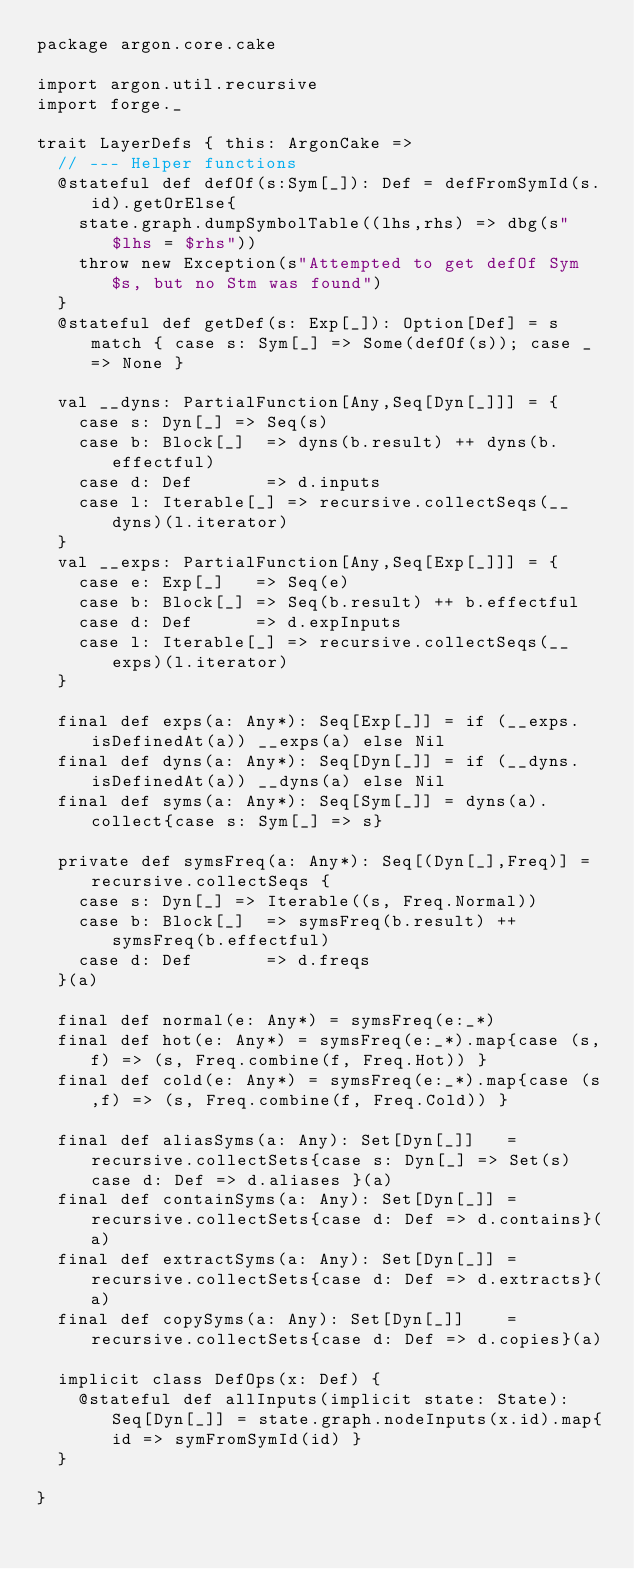<code> <loc_0><loc_0><loc_500><loc_500><_Scala_>package argon.core.cake

import argon.util.recursive
import forge._

trait LayerDefs { this: ArgonCake =>
  // --- Helper functions
  @stateful def defOf(s:Sym[_]): Def = defFromSymId(s.id).getOrElse{
    state.graph.dumpSymbolTable((lhs,rhs) => dbg(s"$lhs = $rhs"))
    throw new Exception(s"Attempted to get defOf Sym $s, but no Stm was found")
  }
  @stateful def getDef(s: Exp[_]): Option[Def] = s match { case s: Sym[_] => Some(defOf(s)); case _ => None }

  val __dyns: PartialFunction[Any,Seq[Dyn[_]]] = {
    case s: Dyn[_] => Seq(s)
    case b: Block[_]  => dyns(b.result) ++ dyns(b.effectful)
    case d: Def       => d.inputs
    case l: Iterable[_] => recursive.collectSeqs(__dyns)(l.iterator)
  }
  val __exps: PartialFunction[Any,Seq[Exp[_]]] = {
    case e: Exp[_]   => Seq(e)
    case b: Block[_] => Seq(b.result) ++ b.effectful
    case d: Def      => d.expInputs
    case l: Iterable[_] => recursive.collectSeqs(__exps)(l.iterator)
  }

  final def exps(a: Any*): Seq[Exp[_]] = if (__exps.isDefinedAt(a)) __exps(a) else Nil
  final def dyns(a: Any*): Seq[Dyn[_]] = if (__dyns.isDefinedAt(a)) __dyns(a) else Nil
  final def syms(a: Any*): Seq[Sym[_]] = dyns(a).collect{case s: Sym[_] => s}

  private def symsFreq(a: Any*): Seq[(Dyn[_],Freq)] = recursive.collectSeqs {
    case s: Dyn[_] => Iterable((s, Freq.Normal))
    case b: Block[_]  => symsFreq(b.result) ++ symsFreq(b.effectful)
    case d: Def       => d.freqs
  }(a)

  final def normal(e: Any*) = symsFreq(e:_*)
  final def hot(e: Any*) = symsFreq(e:_*).map{case (s,f) => (s, Freq.combine(f, Freq.Hot)) }
  final def cold(e: Any*) = symsFreq(e:_*).map{case (s,f) => (s, Freq.combine(f, Freq.Cold)) }

  final def aliasSyms(a: Any): Set[Dyn[_]]   = recursive.collectSets{case s: Dyn[_] => Set(s) case d: Def => d.aliases }(a)
  final def containSyms(a: Any): Set[Dyn[_]] = recursive.collectSets{case d: Def => d.contains}(a)
  final def extractSyms(a: Any): Set[Dyn[_]] = recursive.collectSets{case d: Def => d.extracts}(a)
  final def copySyms(a: Any): Set[Dyn[_]]    = recursive.collectSets{case d: Def => d.copies}(a)

  implicit class DefOps(x: Def) {
    @stateful def allInputs(implicit state: State): Seq[Dyn[_]] = state.graph.nodeInputs(x.id).map{id => symFromSymId(id) }
  }

}
</code> 